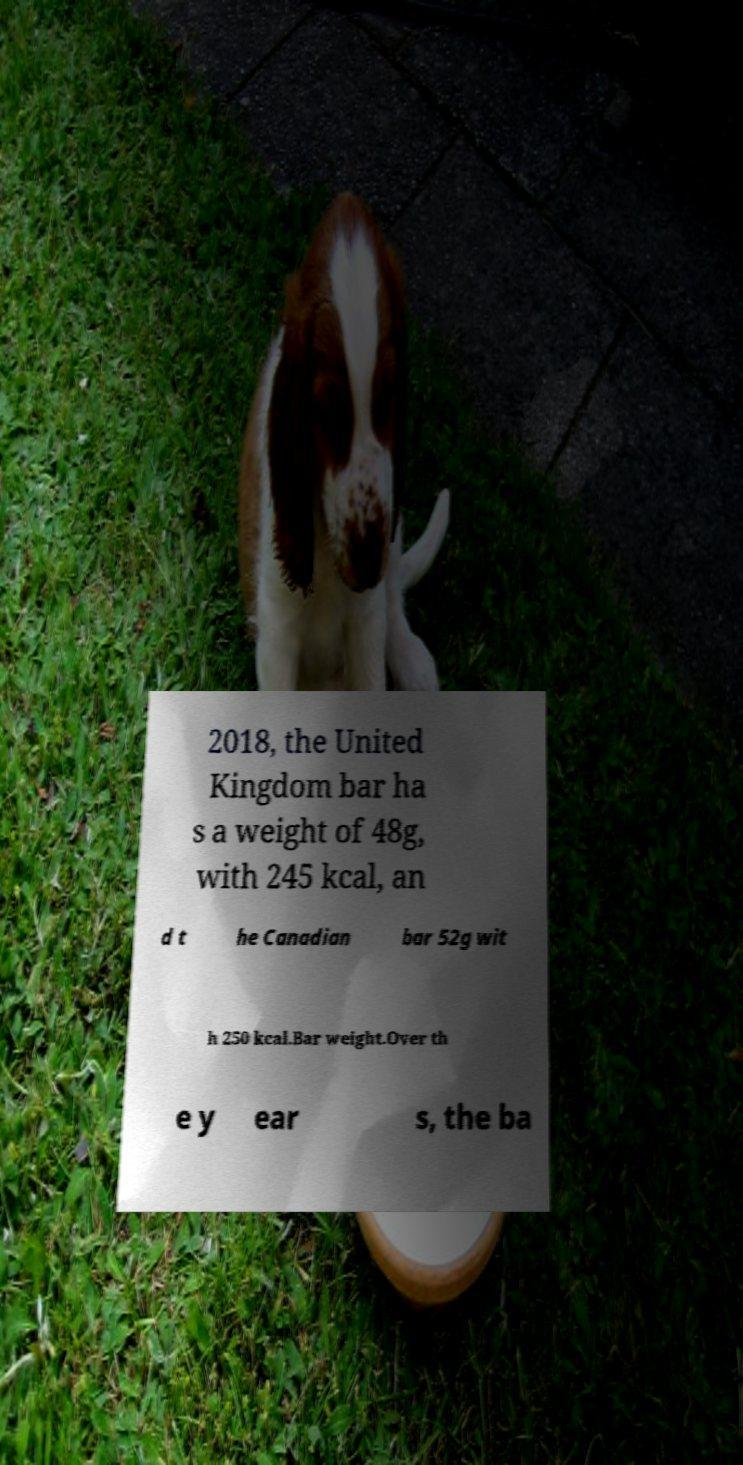Could you assist in decoding the text presented in this image and type it out clearly? 2018, the United Kingdom bar ha s a weight of 48g, with 245 kcal, an d t he Canadian bar 52g wit h 250 kcal.Bar weight.Over th e y ear s, the ba 